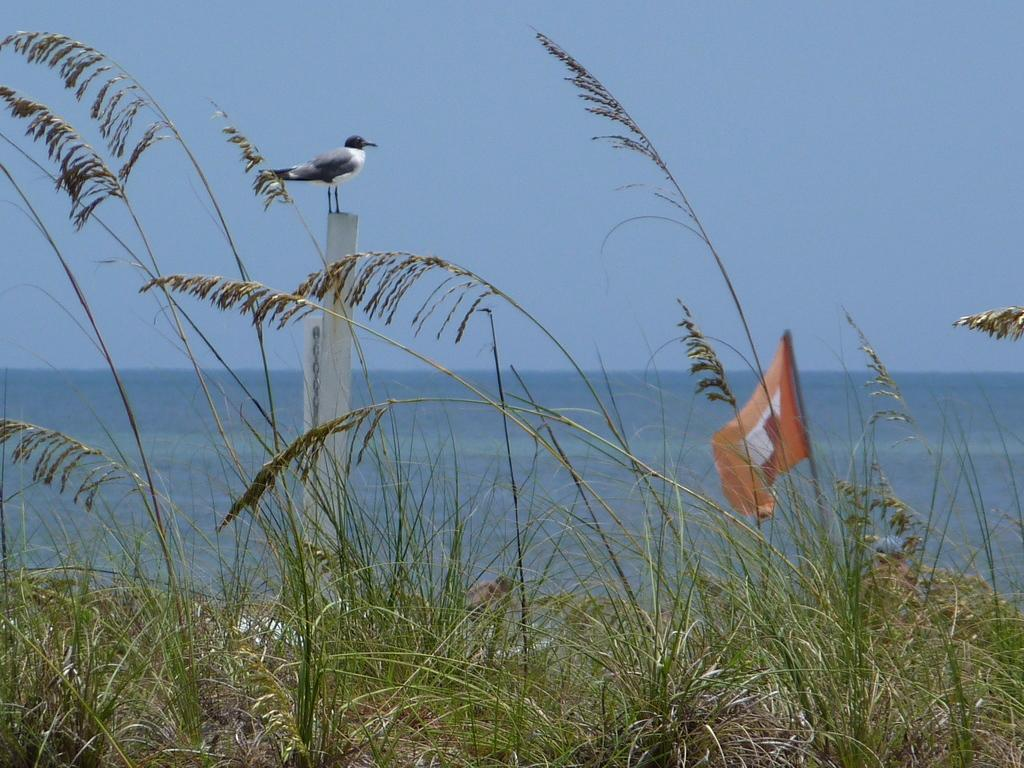What type of vegetation can be seen in the image? There is grass in the image. What is the bird doing in the image? The bird is on a pole in the image. What can be seen besides the grass and bird in the image? There is water visible in the image. What type of border is surrounding the grass in the image? There is no border present in the image; it features grass, a bird on a pole, and water. What word is written on the bird in the image? There are no words written on the bird in the image; it is a bird on a pole. 